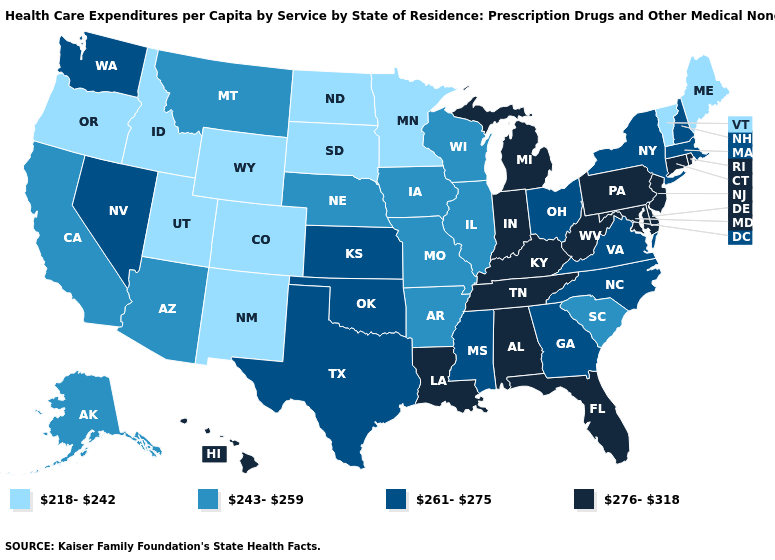Among the states that border Mississippi , does Arkansas have the highest value?
Be succinct. No. Name the states that have a value in the range 243-259?
Short answer required. Alaska, Arizona, Arkansas, California, Illinois, Iowa, Missouri, Montana, Nebraska, South Carolina, Wisconsin. What is the lowest value in the USA?
Concise answer only. 218-242. What is the value of New Hampshire?
Write a very short answer. 261-275. Name the states that have a value in the range 261-275?
Give a very brief answer. Georgia, Kansas, Massachusetts, Mississippi, Nevada, New Hampshire, New York, North Carolina, Ohio, Oklahoma, Texas, Virginia, Washington. Which states have the lowest value in the USA?
Quick response, please. Colorado, Idaho, Maine, Minnesota, New Mexico, North Dakota, Oregon, South Dakota, Utah, Vermont, Wyoming. Among the states that border Illinois , which have the highest value?
Concise answer only. Indiana, Kentucky. What is the value of North Dakota?
Write a very short answer. 218-242. Name the states that have a value in the range 276-318?
Answer briefly. Alabama, Connecticut, Delaware, Florida, Hawaii, Indiana, Kentucky, Louisiana, Maryland, Michigan, New Jersey, Pennsylvania, Rhode Island, Tennessee, West Virginia. Name the states that have a value in the range 276-318?
Short answer required. Alabama, Connecticut, Delaware, Florida, Hawaii, Indiana, Kentucky, Louisiana, Maryland, Michigan, New Jersey, Pennsylvania, Rhode Island, Tennessee, West Virginia. Is the legend a continuous bar?
Give a very brief answer. No. Among the states that border North Carolina , does South Carolina have the highest value?
Concise answer only. No. What is the value of Wyoming?
Quick response, please. 218-242. Name the states that have a value in the range 243-259?
Write a very short answer. Alaska, Arizona, Arkansas, California, Illinois, Iowa, Missouri, Montana, Nebraska, South Carolina, Wisconsin. Does Colorado have the lowest value in the USA?
Keep it brief. Yes. 